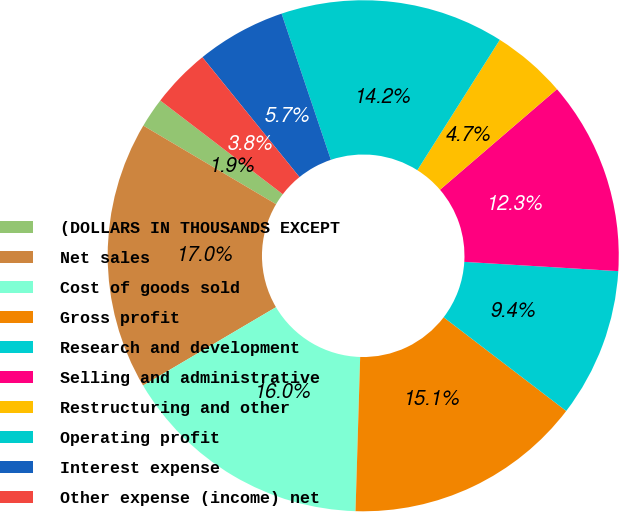Convert chart. <chart><loc_0><loc_0><loc_500><loc_500><pie_chart><fcel>(DOLLARS IN THOUSANDS EXCEPT<fcel>Net sales<fcel>Cost of goods sold<fcel>Gross profit<fcel>Research and development<fcel>Selling and administrative<fcel>Restructuring and other<fcel>Operating profit<fcel>Interest expense<fcel>Other expense (income) net<nl><fcel>1.89%<fcel>16.98%<fcel>16.04%<fcel>15.09%<fcel>9.43%<fcel>12.26%<fcel>4.72%<fcel>14.15%<fcel>5.66%<fcel>3.77%<nl></chart> 